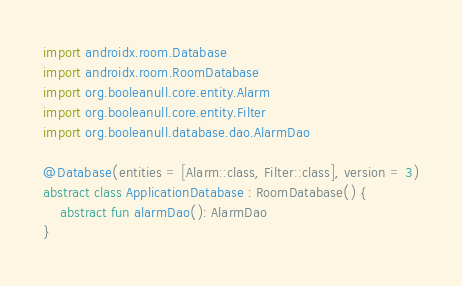<code> <loc_0><loc_0><loc_500><loc_500><_Kotlin_>import androidx.room.Database
import androidx.room.RoomDatabase
import org.booleanull.core.entity.Alarm
import org.booleanull.core.entity.Filter
import org.booleanull.database.dao.AlarmDao

@Database(entities = [Alarm::class, Filter::class], version = 3)
abstract class ApplicationDatabase : RoomDatabase() {
    abstract fun alarmDao(): AlarmDao
}</code> 